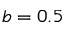Convert formula to latex. <formula><loc_0><loc_0><loc_500><loc_500>b = 0 . 5</formula> 